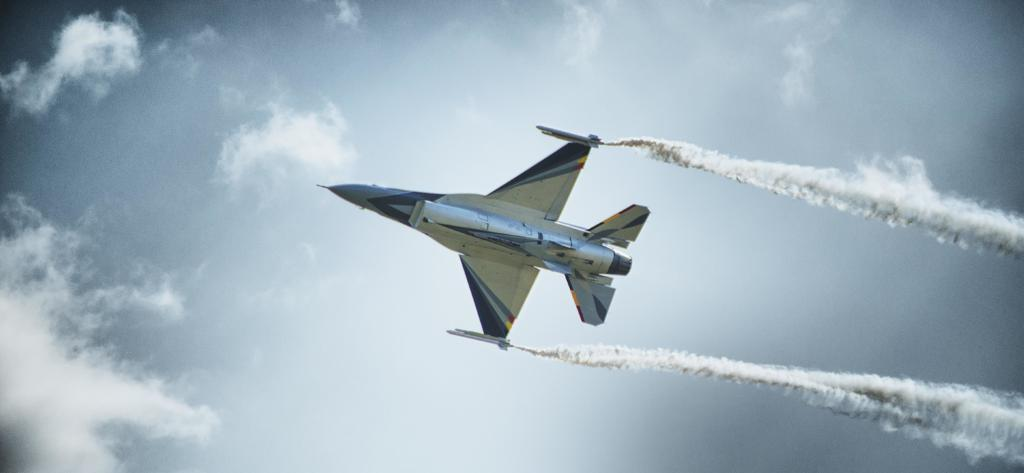What is the main subject of the image? The main subject of the image is an aircraft. Can you describe the position of the aircraft in the image? The aircraft is in the air in the image. What can be seen on the right side of the image? There is smoke on the right side of the image. What is visible in the background of the image? Clouds and the sky are visible in the background of the image. What type of pancake is being pulled by the aircraft in the image? There is no pancake present in the image, nor is there any indication of the aircraft pulling anything. 